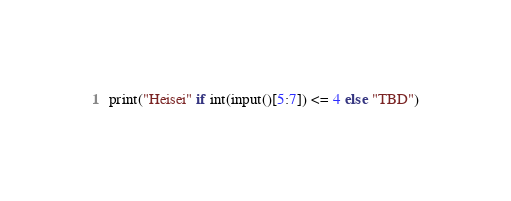<code> <loc_0><loc_0><loc_500><loc_500><_Python_>print("Heisei" if int(input()[5:7]) <= 4 else "TBD")</code> 